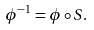<formula> <loc_0><loc_0><loc_500><loc_500>\phi ^ { - 1 } = \phi \circ S .</formula> 